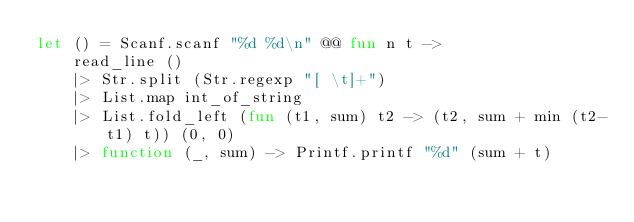<code> <loc_0><loc_0><loc_500><loc_500><_OCaml_>let () = Scanf.scanf "%d %d\n" @@ fun n t ->
    read_line ()
    |> Str.split (Str.regexp "[ \t]+")
    |> List.map int_of_string
    |> List.fold_left (fun (t1, sum) t2 -> (t2, sum + min (t2-t1) t)) (0, 0)
    |> function (_, sum) -> Printf.printf "%d" (sum + t)</code> 